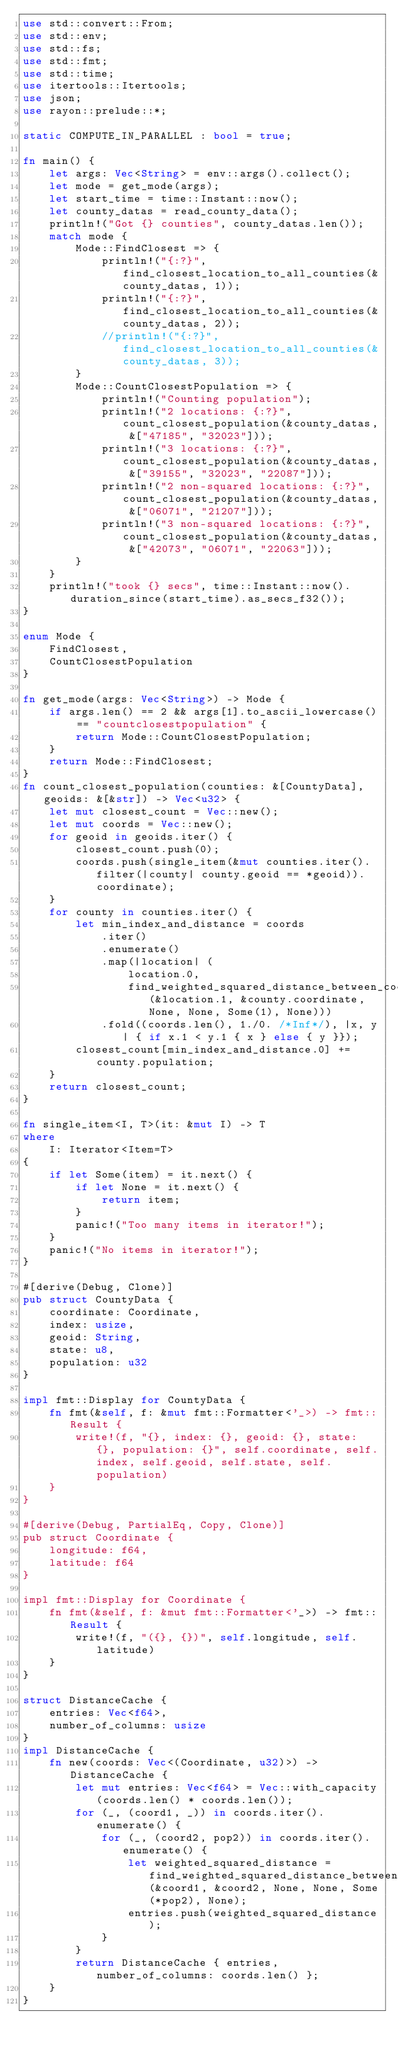<code> <loc_0><loc_0><loc_500><loc_500><_Rust_>use std::convert::From;
use std::env;
use std::fs;
use std::fmt;
use std::time;
use itertools::Itertools;
use json;
use rayon::prelude::*;

static COMPUTE_IN_PARALLEL : bool = true;

fn main() {
    let args: Vec<String> = env::args().collect();
    let mode = get_mode(args);
    let start_time = time::Instant::now();
    let county_datas = read_county_data();
    println!("Got {} counties", county_datas.len());
    match mode {
        Mode::FindClosest => {
            println!("{:?}", find_closest_location_to_all_counties(&county_datas, 1));
            println!("{:?}", find_closest_location_to_all_counties(&county_datas, 2));
            //println!("{:?}", find_closest_location_to_all_counties(&county_datas, 3));
        }
        Mode::CountClosestPopulation => {
            println!("Counting population");
            println!("2 locations: {:?}", count_closest_population(&county_datas, &["47185", "32023"]));
            println!("3 locations: {:?}", count_closest_population(&county_datas, &["39155", "32023", "22087"]));
            println!("2 non-squared locations: {:?}", count_closest_population(&county_datas, &["06071", "21207"]));
            println!("3 non-squared locations: {:?}", count_closest_population(&county_datas, &["42073", "06071", "22063"]));
        }
    }
    println!("took {} secs", time::Instant::now().duration_since(start_time).as_secs_f32());
}

enum Mode {
    FindClosest,
    CountClosestPopulation
}

fn get_mode(args: Vec<String>) -> Mode {
    if args.len() == 2 && args[1].to_ascii_lowercase() == "countclosestpopulation" {
        return Mode::CountClosestPopulation;
    }
    return Mode::FindClosest;
}
fn count_closest_population(counties: &[CountyData], geoids: &[&str]) -> Vec<u32> {
    let mut closest_count = Vec::new();
    let mut coords = Vec::new();
    for geoid in geoids.iter() {
        closest_count.push(0);
        coords.push(single_item(&mut counties.iter().filter(|county| county.geoid == *geoid)).coordinate);
    }
    for county in counties.iter() {
        let min_index_and_distance = coords
            .iter()
            .enumerate()
            .map(|location| (
                location.0,
                find_weighted_squared_distance_between_coordinates(&location.1, &county.coordinate, None, None, Some(1), None)))
            .fold((coords.len(), 1./0. /*Inf*/), |x, y| { if x.1 < y.1 { x } else { y }});
        closest_count[min_index_and_distance.0] += county.population;
    }
    return closest_count;
}

fn single_item<I, T>(it: &mut I) -> T
where 
    I: Iterator<Item=T>
{
    if let Some(item) = it.next() {
        if let None = it.next() {
            return item;
        }
        panic!("Too many items in iterator!");
    }
    panic!("No items in iterator!");
}

#[derive(Debug, Clone)]
pub struct CountyData {
    coordinate: Coordinate,
    index: usize,
    geoid: String,
    state: u8,
    population: u32
}

impl fmt::Display for CountyData {
    fn fmt(&self, f: &mut fmt::Formatter<'_>) -> fmt::Result {
        write!(f, "{}, index: {}, geoid: {}, state: {}, population: {}", self.coordinate, self.index, self.geoid, self.state, self.population)
    }
}

#[derive(Debug, PartialEq, Copy, Clone)]
pub struct Coordinate {
    longitude: f64,
    latitude: f64
}

impl fmt::Display for Coordinate {
    fn fmt(&self, f: &mut fmt::Formatter<'_>) -> fmt::Result {
        write!(f, "({}, {})", self.longitude, self.latitude)
    }
}

struct DistanceCache {
    entries: Vec<f64>,
    number_of_columns: usize
}
impl DistanceCache {
    fn new(coords: Vec<(Coordinate, u32)>) -> DistanceCache {
        let mut entries: Vec<f64> = Vec::with_capacity(coords.len() * coords.len());
        for (_, (coord1, _)) in coords.iter().enumerate() {
            for (_, (coord2, pop2)) in coords.iter().enumerate() {
                let weighted_squared_distance = find_weighted_squared_distance_between_coordinates(&coord1, &coord2, None, None, Some(*pop2), None);
                entries.push(weighted_squared_distance);
            }
        }
        return DistanceCache { entries, number_of_columns: coords.len() };
    }
}

</code> 